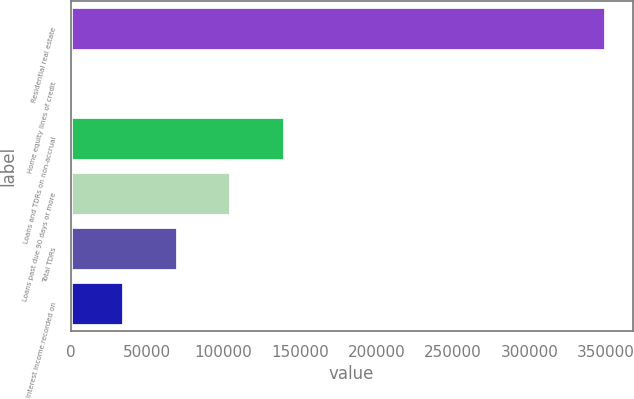Convert chart to OTSL. <chart><loc_0><loc_0><loc_500><loc_500><bar_chart><fcel>Residential real estate<fcel>Home equity lines of credit<fcel>Loans and TDRs on non-accrual<fcel>Loans past due 90 days or more<fcel>Total TDRs<fcel>Interest income recorded on<nl><fcel>349841<fcel>170<fcel>140038<fcel>105071<fcel>70104.2<fcel>35137.1<nl></chart> 